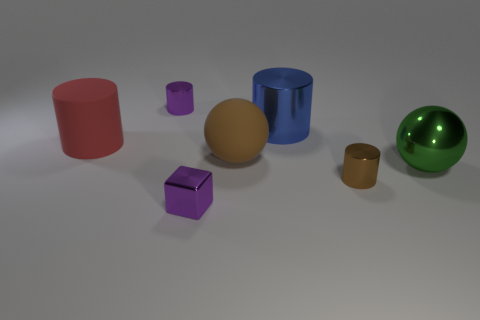Does the block have the same color as the metal cylinder that is to the left of the large brown thing?
Give a very brief answer. Yes. What is the color of the other metallic cylinder that is the same size as the red cylinder?
Give a very brief answer. Blue. Is there a big green object that has the same shape as the big brown thing?
Make the answer very short. Yes. Are there fewer large blue shiny objects than small cyan rubber balls?
Give a very brief answer. No. There is a tiny metallic cylinder behind the tiny brown cylinder; what is its color?
Give a very brief answer. Purple. The tiny purple thing right of the small thing that is on the left side of the metal block is what shape?
Your response must be concise. Cube. Does the large brown thing have the same material as the large ball in front of the large brown rubber thing?
Offer a very short reply. No. There is a shiny thing that is the same color as the tiny cube; what is its shape?
Your response must be concise. Cylinder. How many rubber cylinders are the same size as the brown sphere?
Your answer should be compact. 1. Are there fewer purple objects that are in front of the brown cylinder than large gray cylinders?
Provide a succinct answer. No. 